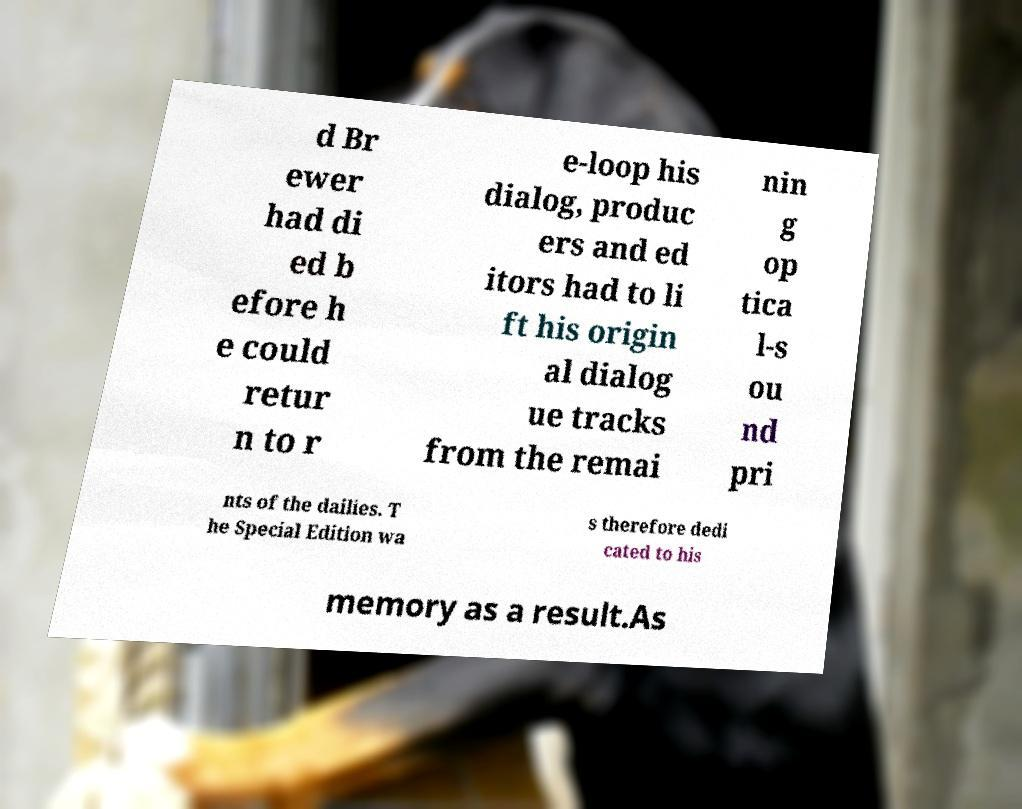Could you extract and type out the text from this image? d Br ewer had di ed b efore h e could retur n to r e-loop his dialog, produc ers and ed itors had to li ft his origin al dialog ue tracks from the remai nin g op tica l-s ou nd pri nts of the dailies. T he Special Edition wa s therefore dedi cated to his memory as a result.As 